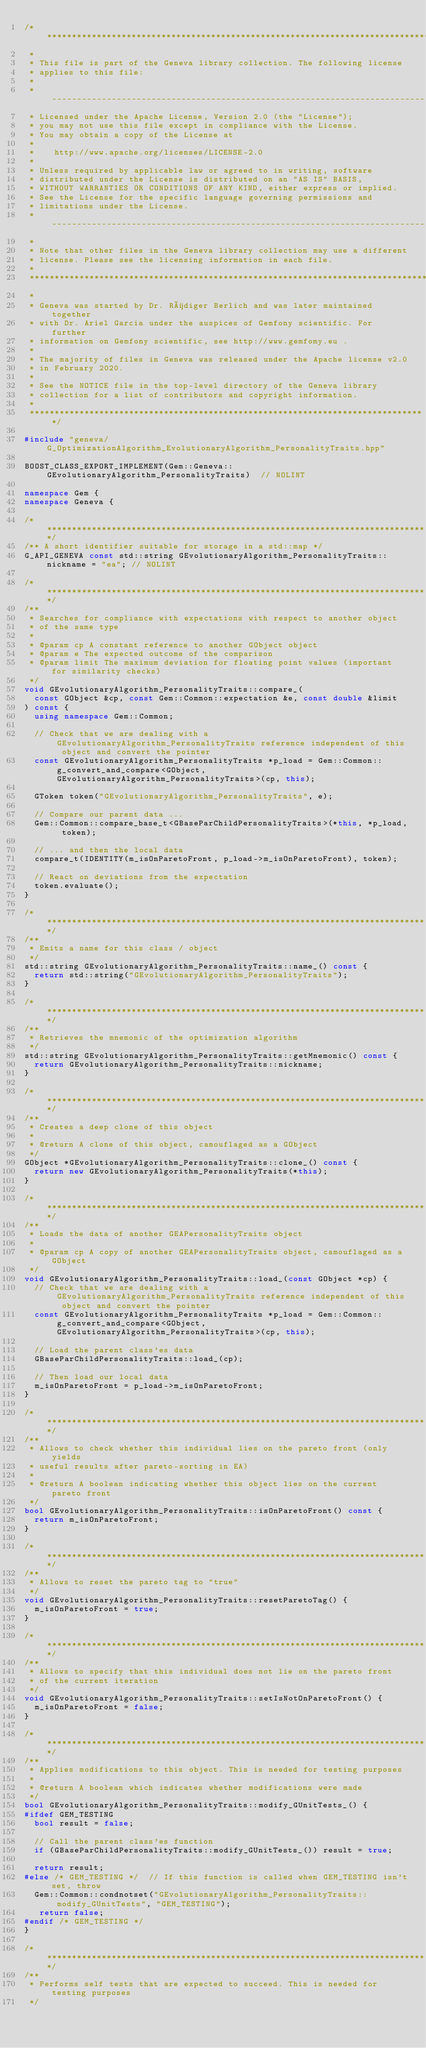<code> <loc_0><loc_0><loc_500><loc_500><_C++_>/********************************************************************************
 *
 * This file is part of the Geneva library collection. The following license
 * applies to this file:
 *
 * ------------------------------------------------------------------------------
 * Licensed under the Apache License, Version 2.0 (the "License");
 * you may not use this file except in compliance with the License.
 * You may obtain a copy of the License at
 *
 *    http://www.apache.org/licenses/LICENSE-2.0
 *
 * Unless required by applicable law or agreed to in writing, software
 * distributed under the License is distributed on an "AS IS" BASIS,
 * WITHOUT WARRANTIES OR CONDITIONS OF ANY KIND, either express or implied.
 * See the License for the specific language governing permissions and
 * limitations under the License.
 * ------------------------------------------------------------------------------
 *
 * Note that other files in the Geneva library collection may use a different
 * license. Please see the licensing information in each file.
 *
 ********************************************************************************
 *
 * Geneva was started by Dr. Rüdiger Berlich and was later maintained together
 * with Dr. Ariel Garcia under the auspices of Gemfony scientific. For further
 * information on Gemfony scientific, see http://www.gemfomy.eu .
 *
 * The majority of files in Geneva was released under the Apache license v2.0
 * in February 2020.
 *
 * See the NOTICE file in the top-level directory of the Geneva library
 * collection for a list of contributors and copyright information.
 *
 ********************************************************************************/

#include "geneva/G_OptimizationAlgorithm_EvolutionaryAlgorithm_PersonalityTraits.hpp"

BOOST_CLASS_EXPORT_IMPLEMENT(Gem::Geneva::GEvolutionaryAlgorithm_PersonalityTraits)  // NOLINT

namespace Gem {
namespace Geneva {

/******************************************************************************/
/** A short identifier suitable for storage in a std::map */
G_API_GENEVA const std::string GEvolutionaryAlgorithm_PersonalityTraits::nickname = "ea"; // NOLINT

/******************************************************************************/
/**
 * Searches for compliance with expectations with respect to another object
 * of the same type
 *
 * @param cp A constant reference to another GObject object
 * @param e The expected outcome of the comparison
 * @param limit The maximum deviation for floating point values (important for similarity checks)
 */
void GEvolutionaryAlgorithm_PersonalityTraits::compare_(
	const GObject &cp, const Gem::Common::expectation &e, const double &limit
) const {
	using namespace Gem::Common;

	// Check that we are dealing with a GEvolutionaryAlgorithm_PersonalityTraits reference independent of this object and convert the pointer
	const GEvolutionaryAlgorithm_PersonalityTraits *p_load = Gem::Common::g_convert_and_compare<GObject, GEvolutionaryAlgorithm_PersonalityTraits>(cp, this);

	GToken token("GEvolutionaryAlgorithm_PersonalityTraits", e);

	// Compare our parent data ...
	Gem::Common::compare_base_t<GBaseParChildPersonalityTraits>(*this, *p_load, token);

	// ... and then the local data
	compare_t(IDENTITY(m_isOnParetoFront, p_load->m_isOnParetoFront), token);

	// React on deviations from the expectation
	token.evaluate();
}

/******************************************************************************/
/**
 * Emits a name for this class / object
 */
std::string GEvolutionaryAlgorithm_PersonalityTraits::name_() const {
	return std::string("GEvolutionaryAlgorithm_PersonalityTraits");
}

/******************************************************************************/
/**
 * Retrieves the mnemonic of the optimization algorithm
 */
std::string GEvolutionaryAlgorithm_PersonalityTraits::getMnemonic() const {
	return GEvolutionaryAlgorithm_PersonalityTraits::nickname;
}

/******************************************************************************/
/**
 * Creates a deep clone of this object
 *
 * @return A clone of this object, camouflaged as a GObject
 */
GObject *GEvolutionaryAlgorithm_PersonalityTraits::clone_() const {
	return new GEvolutionaryAlgorithm_PersonalityTraits(*this);
}

/******************************************************************************/
/**
 * Loads the data of another GEAPersonalityTraits object
 *
 * @param cp A copy of another GEAPersonalityTraits object, camouflaged as a GObject
 */
void GEvolutionaryAlgorithm_PersonalityTraits::load_(const GObject *cp) {
	// Check that we are dealing with a GEvolutionaryAlgorithm_PersonalityTraits reference independent of this object and convert the pointer
	const GEvolutionaryAlgorithm_PersonalityTraits *p_load = Gem::Common::g_convert_and_compare<GObject, GEvolutionaryAlgorithm_PersonalityTraits>(cp, this);

	// Load the parent class'es data
	GBaseParChildPersonalityTraits::load_(cp);

	// Then load our local data
	m_isOnParetoFront = p_load->m_isOnParetoFront;
}

/******************************************************************************/
/**
 * Allows to check whether this individual lies on the pareto front (only yields
 * useful results after pareto-sorting in EA)
 *
 * @return A boolean indicating whether this object lies on the current pareto front
 */
bool GEvolutionaryAlgorithm_PersonalityTraits::isOnParetoFront() const {
	return m_isOnParetoFront;
}

/******************************************************************************/
/**
 * Allows to reset the pareto tag to "true"
 */
void GEvolutionaryAlgorithm_PersonalityTraits::resetParetoTag() {
	m_isOnParetoFront = true;
}

/******************************************************************************/
/**
 * Allows to specify that this individual does not lie on the pareto front
 * of the current iteration
 */
void GEvolutionaryAlgorithm_PersonalityTraits::setIsNotOnParetoFront() {
	m_isOnParetoFront = false;
}

/******************************************************************************/
/**
 * Applies modifications to this object. This is needed for testing purposes
 *
 * @return A boolean which indicates whether modifications were made
 */
bool GEvolutionaryAlgorithm_PersonalityTraits::modify_GUnitTests_() {
#ifdef GEM_TESTING
	bool result = false;

	// Call the parent class'es function
	if (GBaseParChildPersonalityTraits::modify_GUnitTests_()) result = true;

	return result;
#else /* GEM_TESTING */  // If this function is called when GEM_TESTING isn't set, throw
	Gem::Common::condnotset("GEvolutionaryAlgorithm_PersonalityTraits::modify_GUnitTests", "GEM_TESTING");
   return false;
#endif /* GEM_TESTING */
}

/******************************************************************************/
/**
 * Performs self tests that are expected to succeed. This is needed for testing purposes
 */</code> 